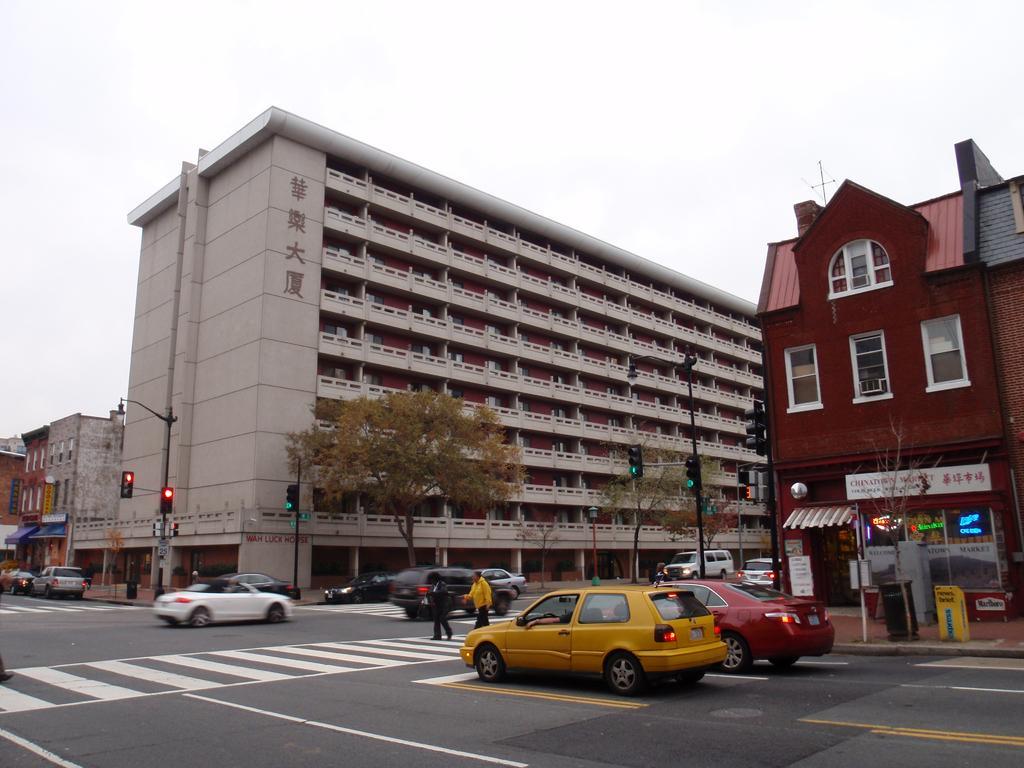In one or two sentences, can you explain what this image depicts? There are cars on the road. Here we can see trees, poles, traffic signals, bin, boards, and buildings. Here we can see two persons on the road. In the background there is sky. 